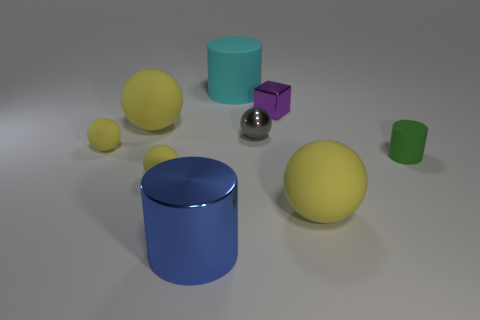How many yellow spheres must be subtracted to get 2 yellow spheres? 2 Subtract all red cylinders. How many yellow spheres are left? 4 Subtract all large yellow rubber balls. How many balls are left? 3 Subtract 1 spheres. How many spheres are left? 4 Subtract all gray balls. How many balls are left? 4 Subtract all blue balls. Subtract all yellow cubes. How many balls are left? 5 Subtract all cylinders. How many objects are left? 6 Add 1 tiny red metal cylinders. How many objects exist? 10 Subtract all small purple shiny things. Subtract all big cyan objects. How many objects are left? 7 Add 1 big yellow spheres. How many big yellow spheres are left? 3 